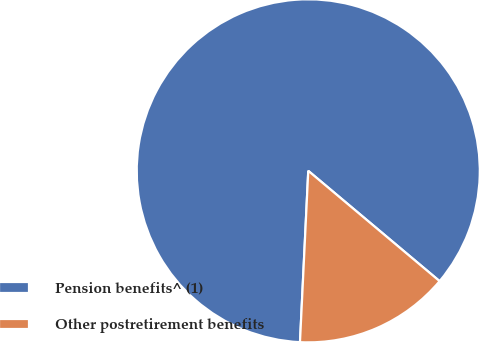Convert chart. <chart><loc_0><loc_0><loc_500><loc_500><pie_chart><fcel>Pension benefits^ (1)<fcel>Other postretirement benefits<nl><fcel>85.35%<fcel>14.65%<nl></chart> 